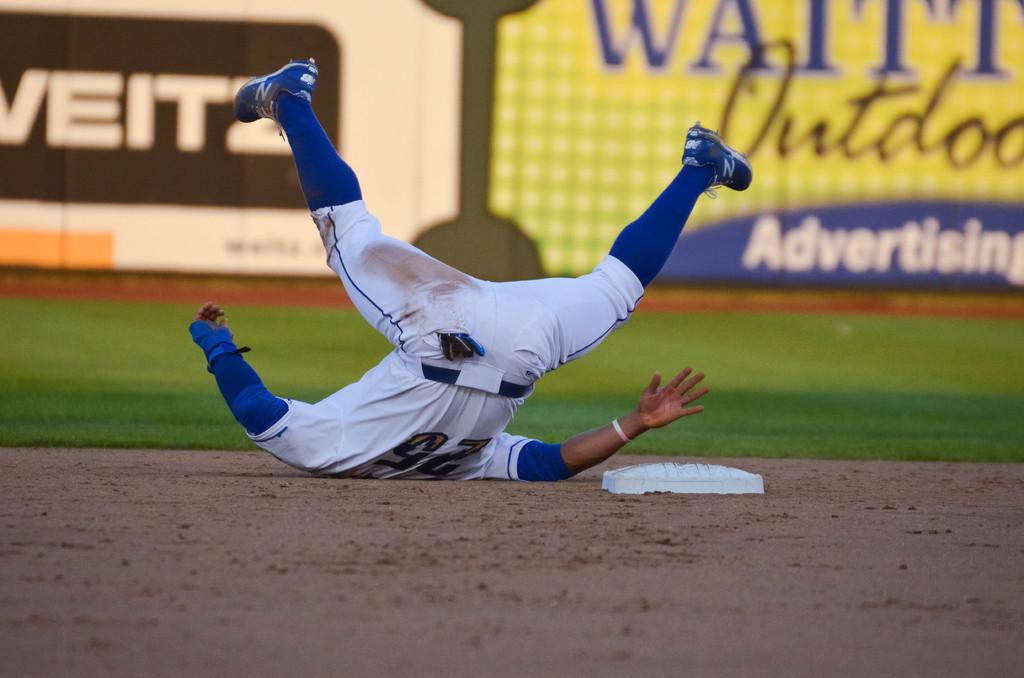<image>
Render a clear and concise summary of the photo. number 25 player fell on his back near a base mat 